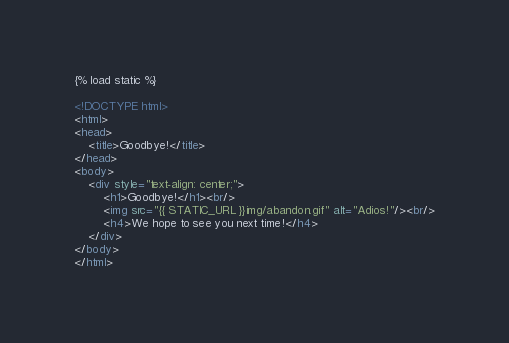Convert code to text. <code><loc_0><loc_0><loc_500><loc_500><_HTML_>{% load static %}

<!DOCTYPE html>
<html>
<head>
    <title>Goodbye!</title>
</head>
<body>
    <div style="text-align: center;">
        <h1>Goodbye!</h1><br/>
        <img src="{{ STATIC_URL }}img/abandon.gif" alt="Adios!"/><br/>
        <h4>We hope to see you next time!</h4>
    </div>
</body>
</html></code> 